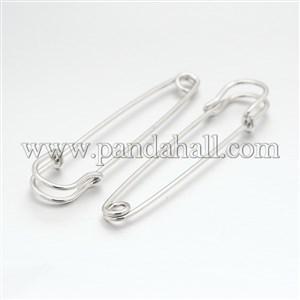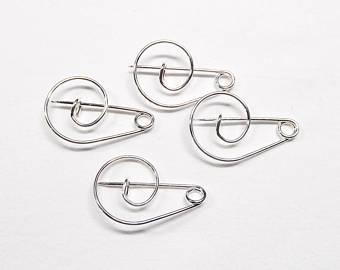The first image is the image on the left, the second image is the image on the right. Evaluate the accuracy of this statement regarding the images: "There are four safety pins.". Is it true? Answer yes or no. No. The first image is the image on the left, the second image is the image on the right. For the images shown, is this caption "There's at least one open safety pin." true? Answer yes or no. No. 